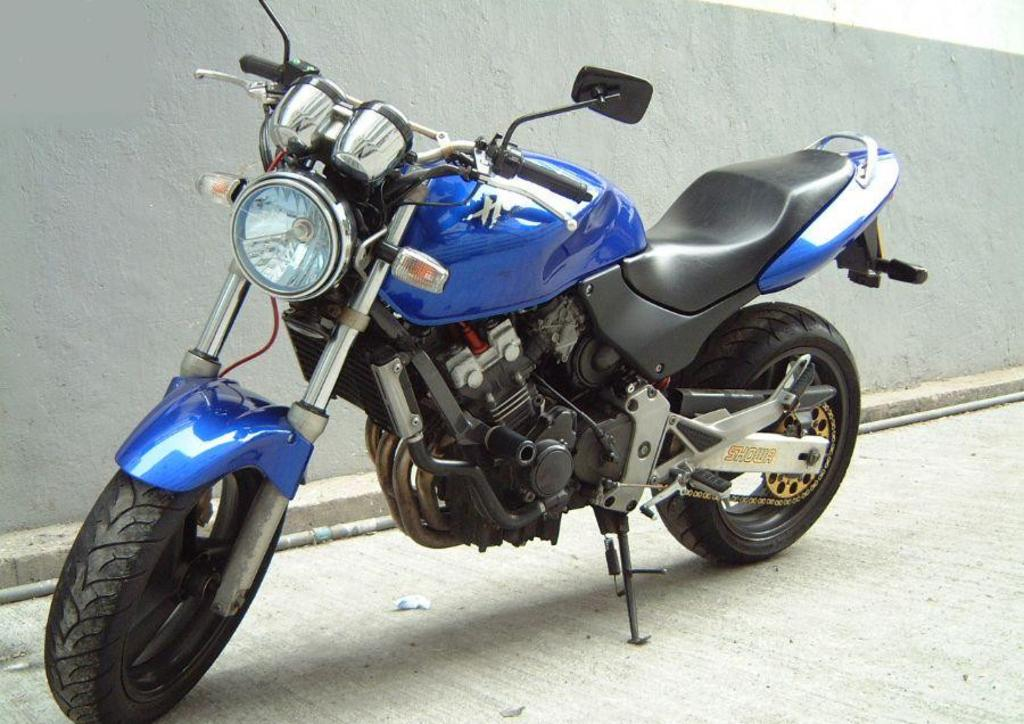What type of vehicle is in the image? There is a blue bike in the image. Where is the bike located? The bike is parked on a path. What is visible behind the bike? There is a wall behind the bike. Can you tell me how the girl is skateboarding on the bike in the image? There is no girl or skateboard present in the image; it features a blue bike parked on a path. 